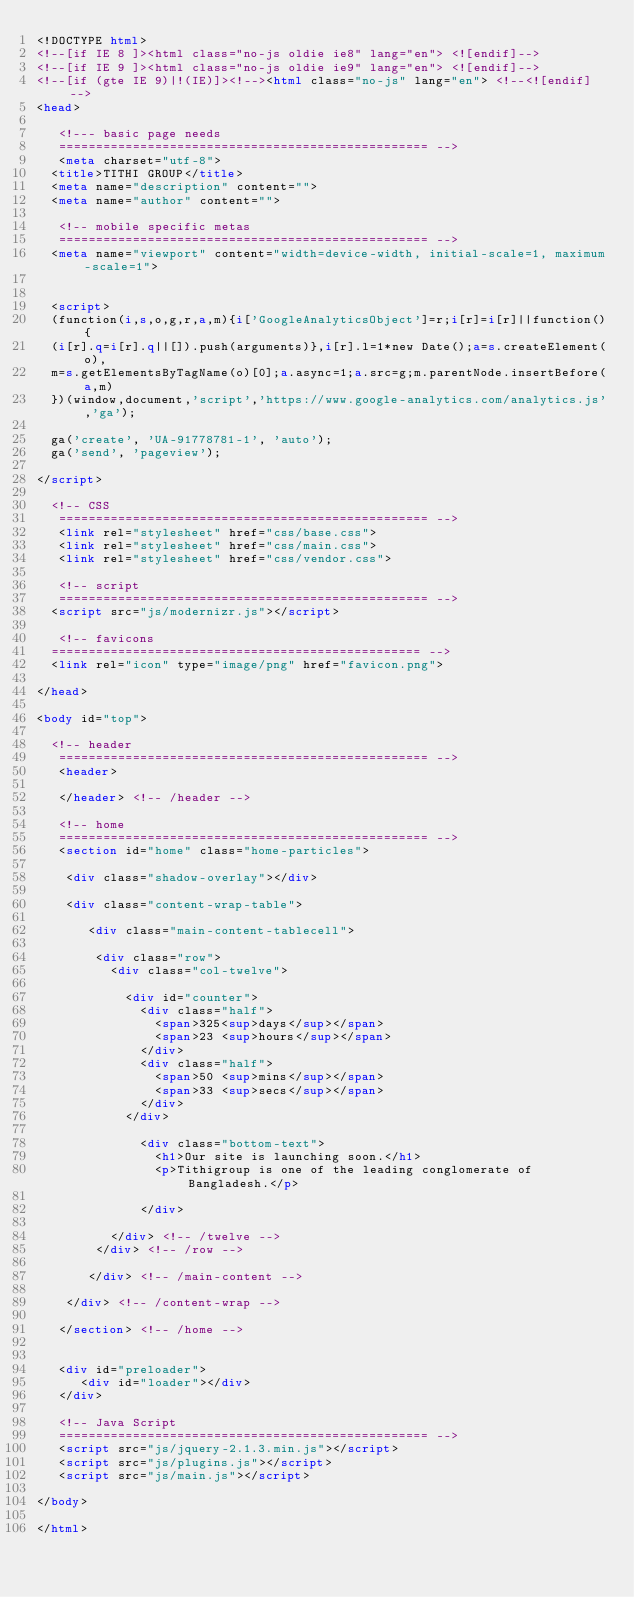<code> <loc_0><loc_0><loc_500><loc_500><_HTML_><!DOCTYPE html>
<!--[if IE 8 ]><html class="no-js oldie ie8" lang="en"> <![endif]-->
<!--[if IE 9 ]><html class="no-js oldie ie9" lang="en"> <![endif]-->
<!--[if (gte IE 9)|!(IE)]><!--><html class="no-js" lang="en"> <!--<![endif]-->
<head>

   <!--- basic page needs
   ================================================== -->
   <meta charset="utf-8">
	<title>TITHI GROUP</title>
	<meta name="description" content="">  
	<meta name="author" content="">

   <!-- mobile specific metas
   ================================================== -->
	<meta name="viewport" content="width=device-width, initial-scale=1, maximum-scale=1">

 	
	<script>
  (function(i,s,o,g,r,a,m){i['GoogleAnalyticsObject']=r;i[r]=i[r]||function(){
  (i[r].q=i[r].q||[]).push(arguments)},i[r].l=1*new Date();a=s.createElement(o),
  m=s.getElementsByTagName(o)[0];a.async=1;a.src=g;m.parentNode.insertBefore(a,m)
  })(window,document,'script','https://www.google-analytics.com/analytics.js','ga');

  ga('create', 'UA-91778781-1', 'auto');
  ga('send', 'pageview');

</script>
	
	<!-- CSS
   ================================================== -->
   <link rel="stylesheet" href="css/base.css">  
   <link rel="stylesheet" href="css/main.css">
   <link rel="stylesheet" href="css/vendor.css">

   <!-- script
   ================================================== -->
	<script src="js/modernizr.js"></script>

   <!-- favicons
	================================================== -->
	<link rel="icon" type="image/png" href="favicon.png">

</head>

<body id="top">

	<!-- header 
   ================================================== -->
   <header>

   </header> <!-- /header -->   

   <!-- home
   ================================================== -->
   <section id="home" class="home-particles">

   	<div class="shadow-overlay"></div>

   	<div class="content-wrap-table">		   

		   <div class="main-content-tablecell">

		   	<div class="row">
		   		<div class="col-twelve">

		   			<div id="counter">
		   				<div class="half">
		   					<span>325<sup>days</sup></span> 
		 						<span>23 <sup>hours</sup></span>
		   				</div>
							<div class="half">
								<span>50 <sup>mins</sup></span>
		 						<span>33 <sup>secs</sup></span>
		 					</div> 
		   			</div>

			  			<div class="bottom-text">
			  				<h1>Our site is launching soon.</h1>
			  				<p>Tithigroup is one of the leading conglomerate of Bangladesh.</p>
				  				  				
			  			</div>			  						  			   			

			   	</div> <!-- /twelve --> 
		   	</div> <!-- /row -->  

		   </div> <!-- /main-content --> 
		   
		</div> <!-- /content-wrap -->
   
   </section> <!-- /home -->


   <div id="preloader"> 
    	<div id="loader"></div>
   </div> 

   <!-- Java Script
   ================================================== --> 
   <script src="js/jquery-2.1.3.min.js"></script>
   <script src="js/plugins.js"></script>
   <script src="js/main.js"></script>

</body>

</html>
</code> 